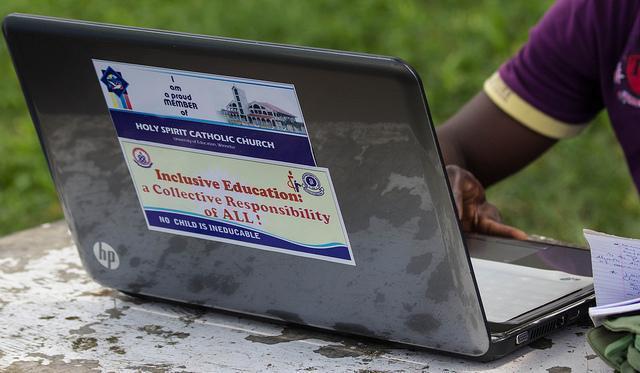How many street signs with a horse in it?
Give a very brief answer. 0. 